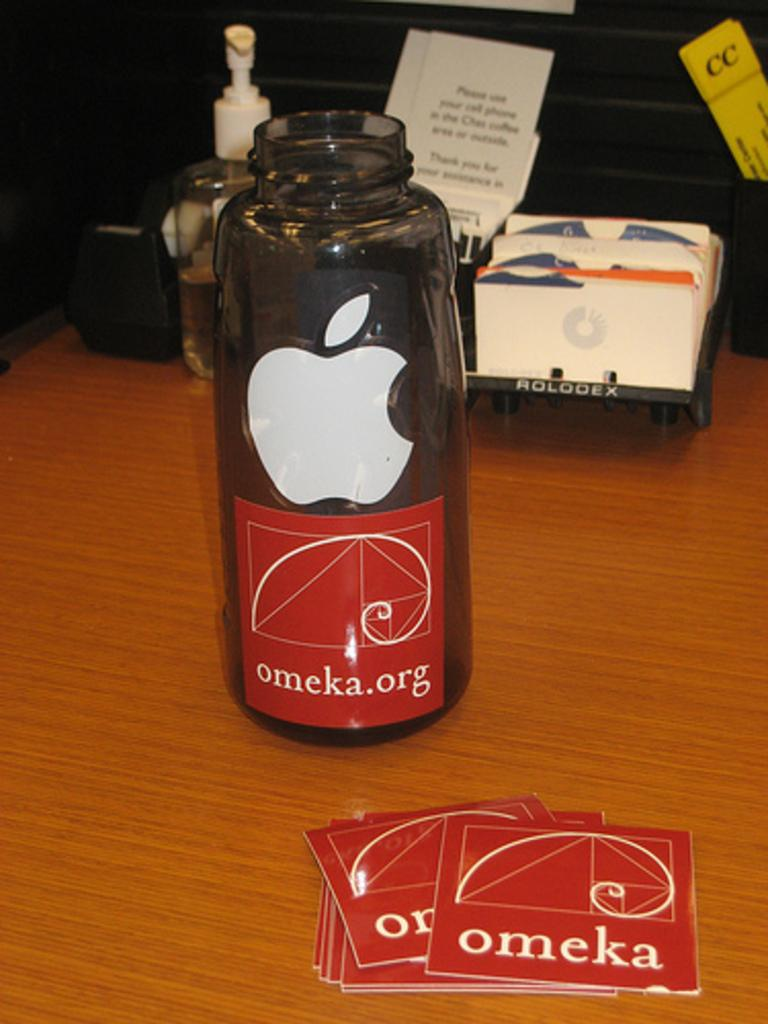<image>
Write a terse but informative summary of the picture. A water bottle with an Apple sticker and an omeka.org sticker on it. 